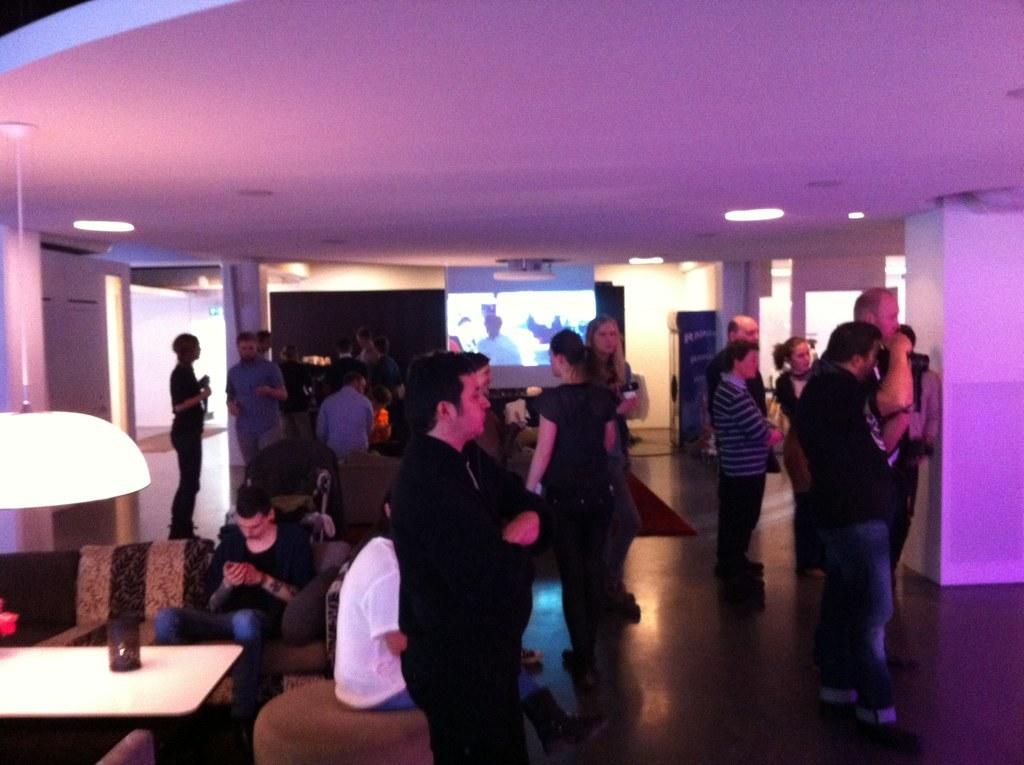How many people are in the image? There is a group of people in the image. What are the people doing in the image? Some people are sitting on a sofa, while others are standing on the floor. What is the purpose of the projector screen in the image? The presence of a projector screen suggests that the people might be watching a presentation or movie. What color is the table in the image? There is a white color table in the image. What type of meal is being served on the table in the image? There is no meal present on the table in the image; it is a white color table with no food or dishes visible. 